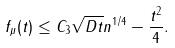<formula> <loc_0><loc_0><loc_500><loc_500>f _ { \mu } ( t ) \leq C _ { 3 } \sqrt { D t } n ^ { 1 / 4 } - \frac { t ^ { 2 } } { 4 } .</formula> 